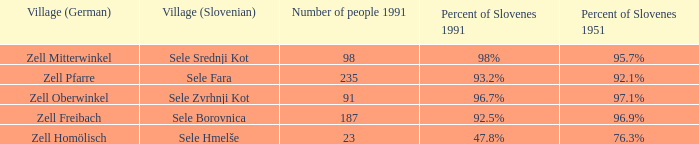Give me the minimum number of people in 1991 with 92.5% of Slovenes in 1991. 187.0. 